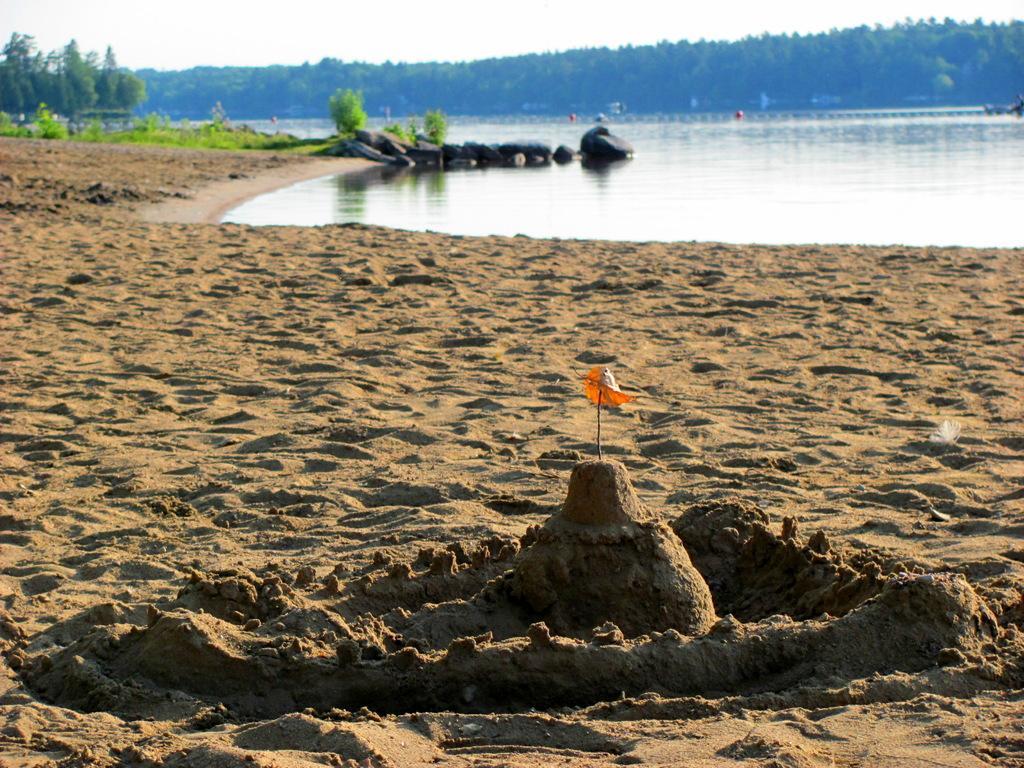Could you give a brief overview of what you see in this image? In the foreground I can see sand, water, some objects, grass, trees, fence and a group of people in the water. In the background I can see mountains and the sky. This image is taken may be near the lake. 